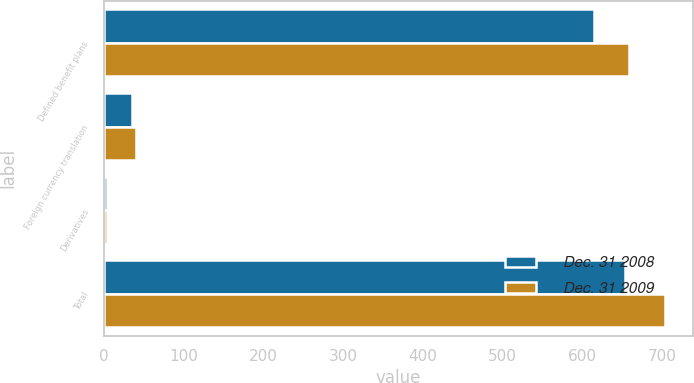Convert chart. <chart><loc_0><loc_0><loc_500><loc_500><stacked_bar_chart><ecel><fcel>Defined benefit plans<fcel>Foreign currency translation<fcel>Derivatives<fcel>Total<nl><fcel>Dec. 31 2008<fcel>615<fcel>35<fcel>4<fcel>654<nl><fcel>Dec. 31 2009<fcel>659<fcel>41<fcel>4<fcel>704<nl></chart> 